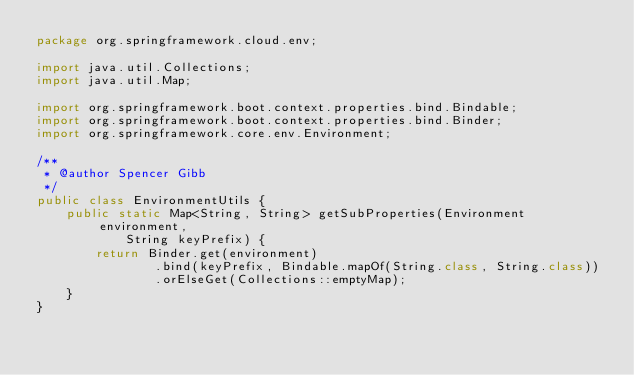Convert code to text. <code><loc_0><loc_0><loc_500><loc_500><_Java_>package org.springframework.cloud.env;

import java.util.Collections;
import java.util.Map;

import org.springframework.boot.context.properties.bind.Bindable;
import org.springframework.boot.context.properties.bind.Binder;
import org.springframework.core.env.Environment;

/**
 * @author Spencer Gibb
 */
public class EnvironmentUtils {
	public static Map<String, String> getSubProperties(Environment environment,
			String keyPrefix) {
		return Binder.get(environment)
				.bind(keyPrefix, Bindable.mapOf(String.class, String.class))
				.orElseGet(Collections::emptyMap);
	}
}
</code> 